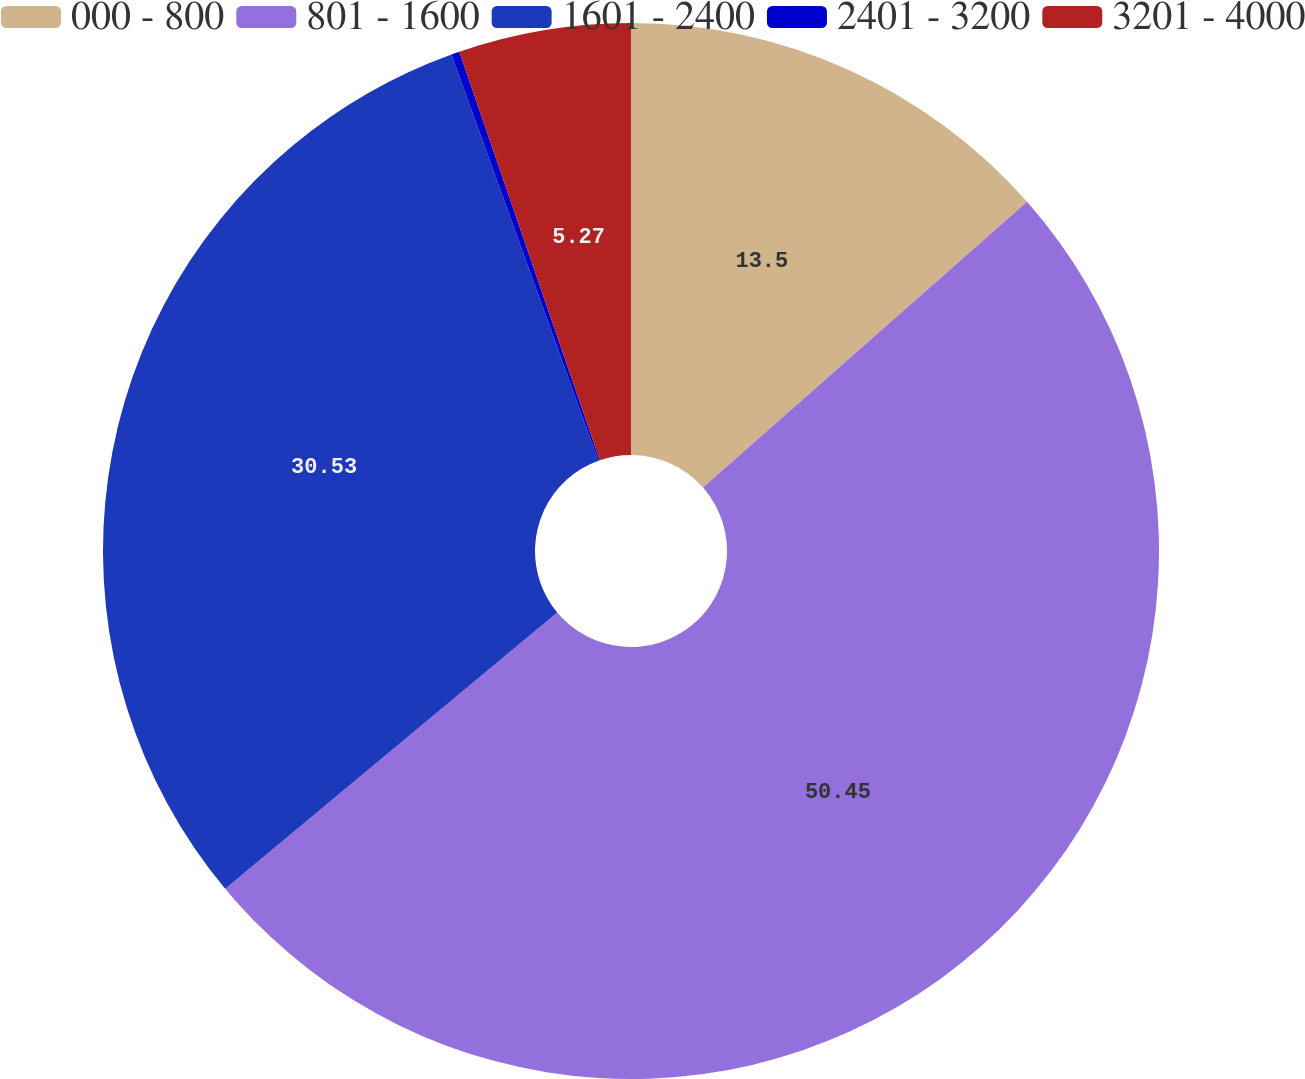<chart> <loc_0><loc_0><loc_500><loc_500><pie_chart><fcel>000 - 800<fcel>801 - 1600<fcel>1601 - 2400<fcel>2401 - 3200<fcel>3201 - 4000<nl><fcel>13.5%<fcel>50.45%<fcel>30.53%<fcel>0.25%<fcel>5.27%<nl></chart> 